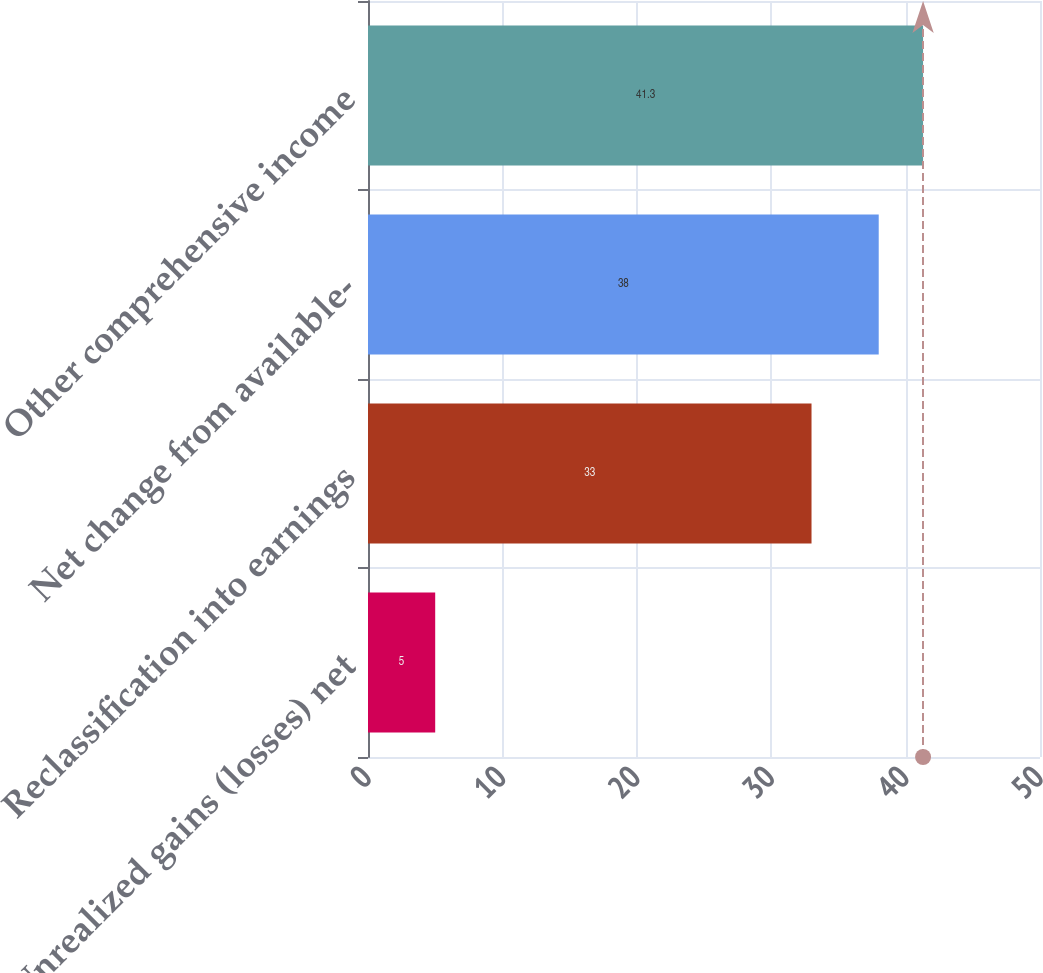Convert chart to OTSL. <chart><loc_0><loc_0><loc_500><loc_500><bar_chart><fcel>Unrealized gains (losses) net<fcel>Reclassification into earnings<fcel>Net change from available-<fcel>Other comprehensive income<nl><fcel>5<fcel>33<fcel>38<fcel>41.3<nl></chart> 